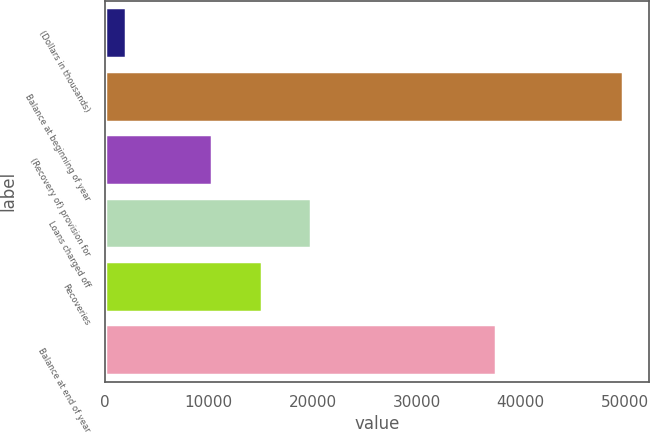Convert chart to OTSL. <chart><loc_0><loc_0><loc_500><loc_500><bar_chart><fcel>(Dollars in thousands)<fcel>Balance at beginning of year<fcel>(Recovery of) provision for<fcel>Loans charged off<fcel>Recoveries<fcel>Balance at end of year<nl><fcel>2004<fcel>49862<fcel>10289<fcel>19860.6<fcel>15074.8<fcel>37613<nl></chart> 